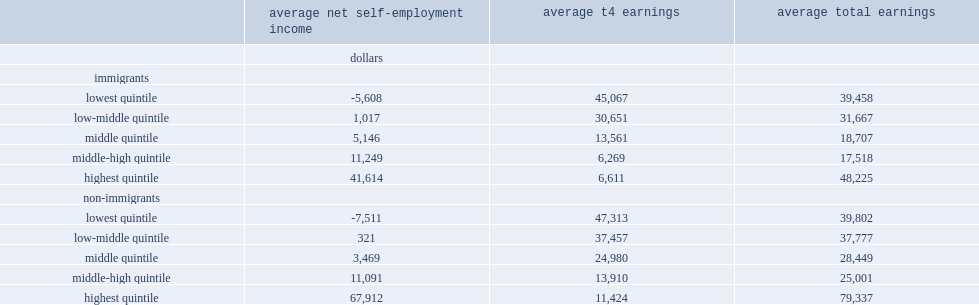How much did the bottom 20% of self-employed earners have average net self-employment earnings among immigrants? -5608.0. How much did the next quintile had average net self-employment earnings among immigrants? 1017.0. 